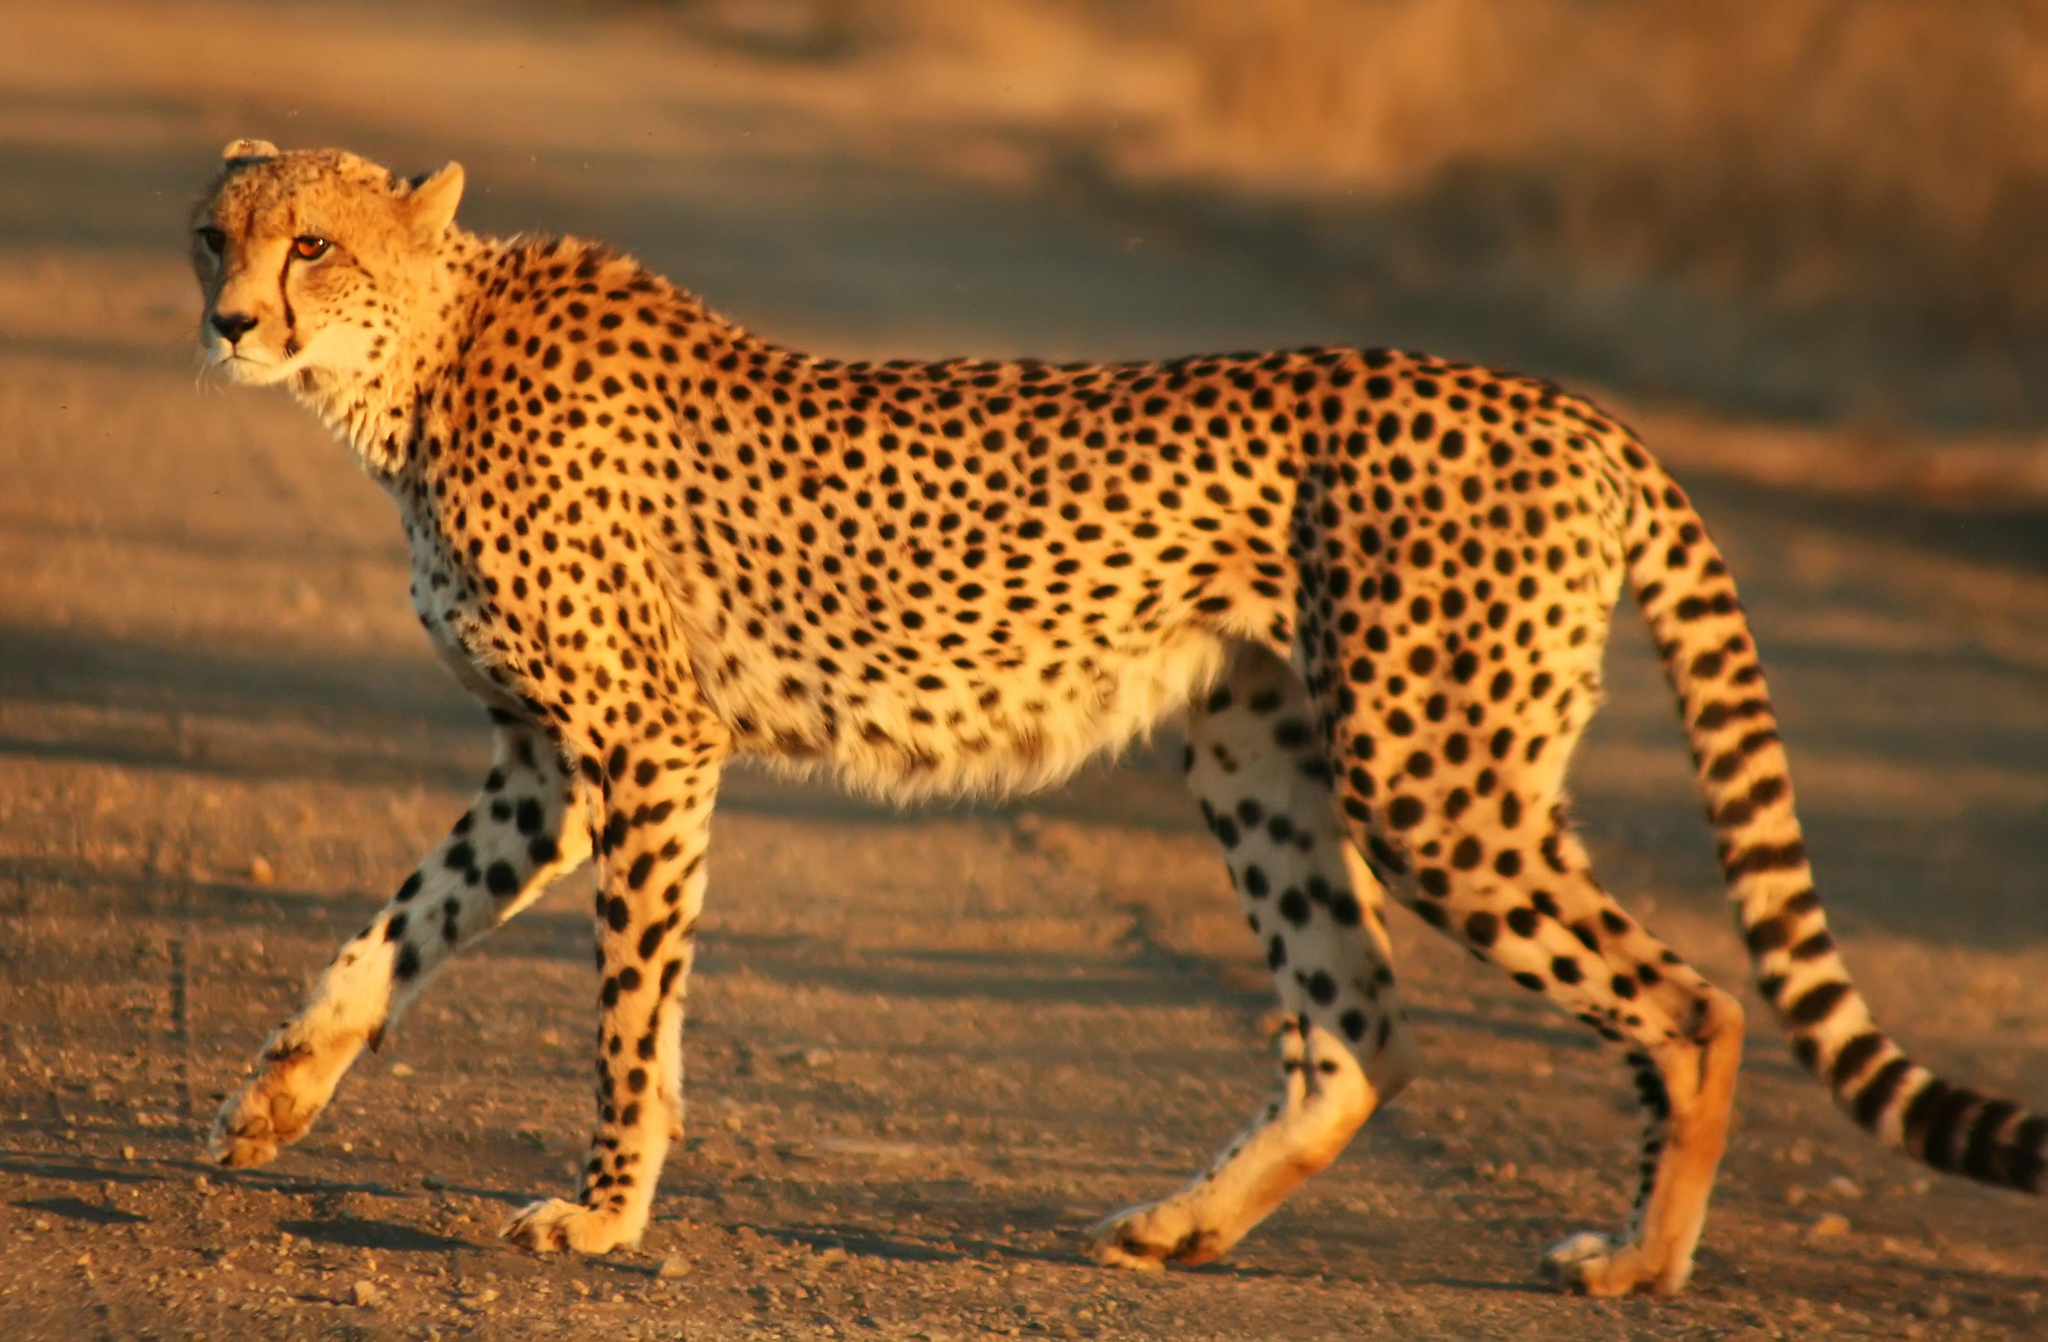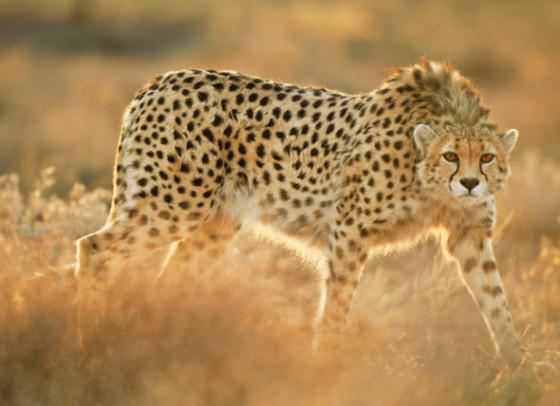The first image is the image on the left, the second image is the image on the right. Considering the images on both sides, is "At least one image contains multiple cheetahs." valid? Answer yes or no. No. 